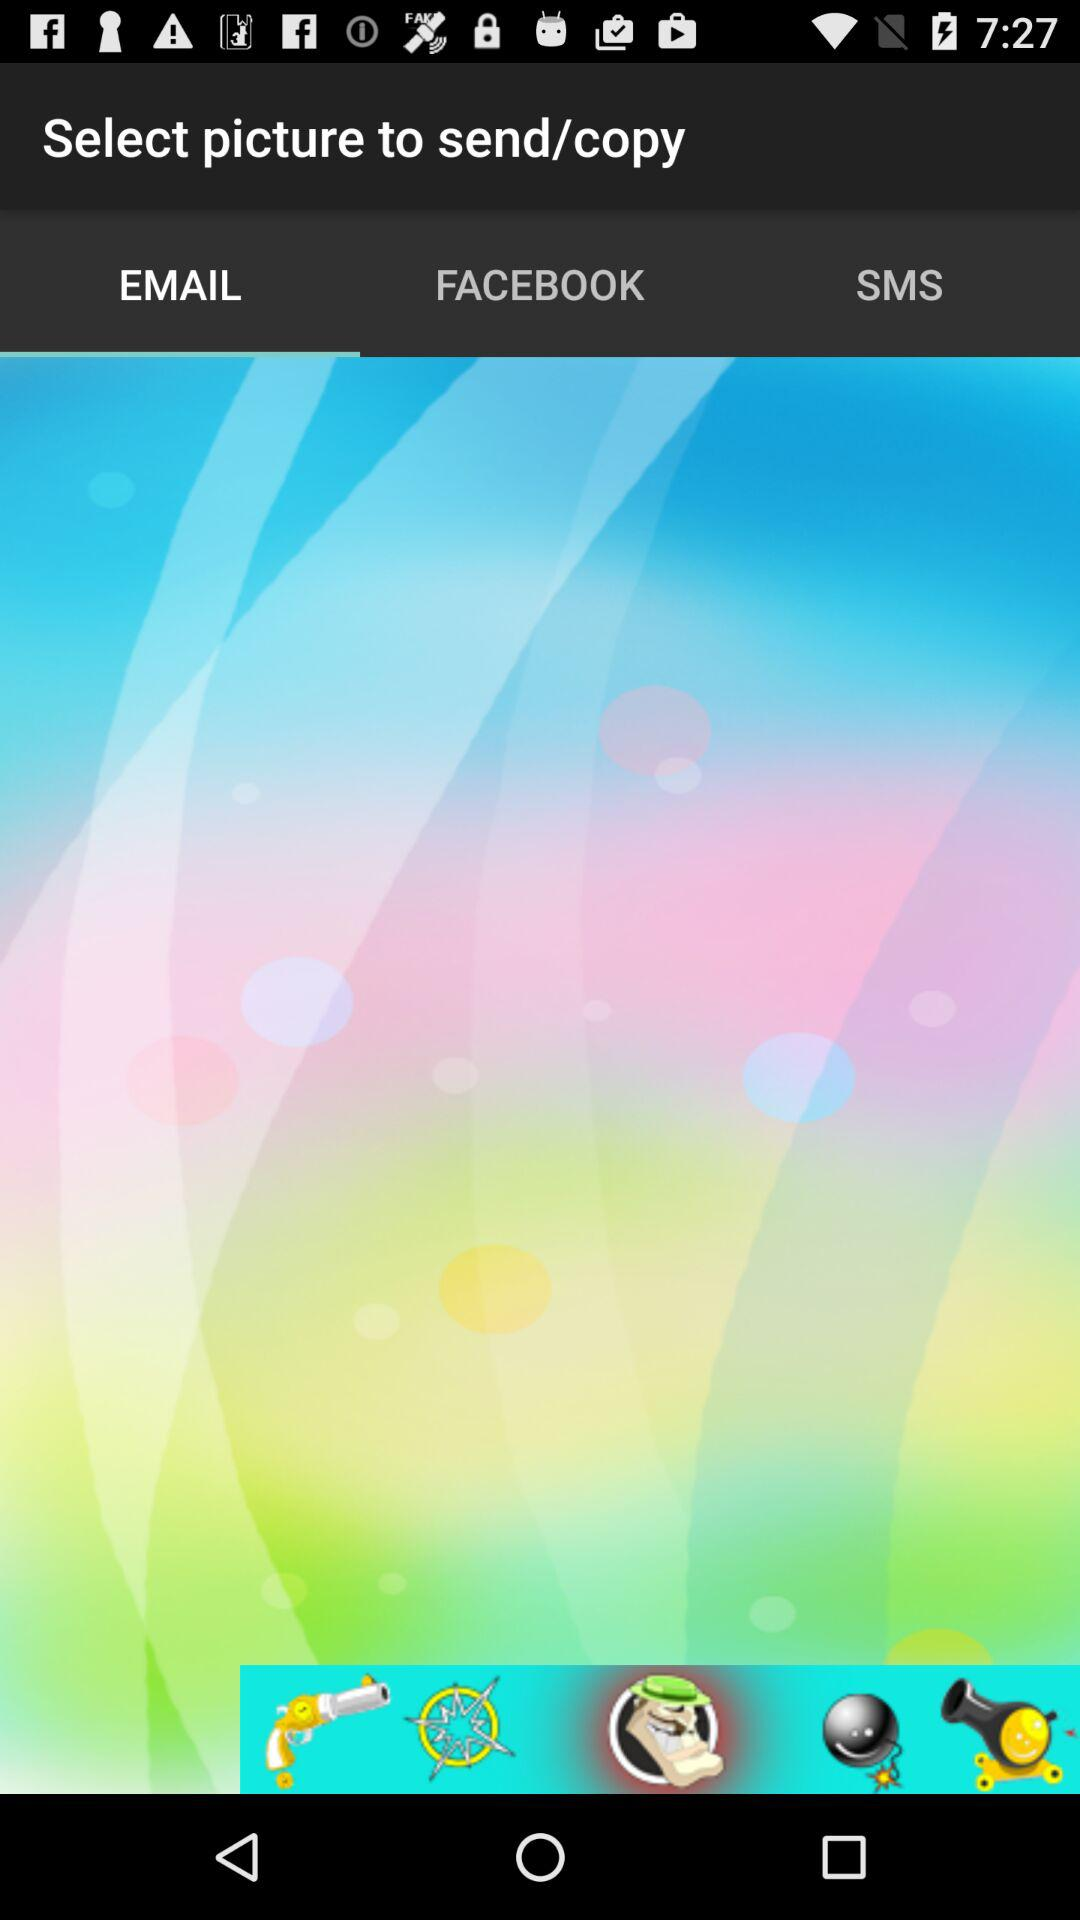Which tab is selected? The selected tab is "EMAIL". 